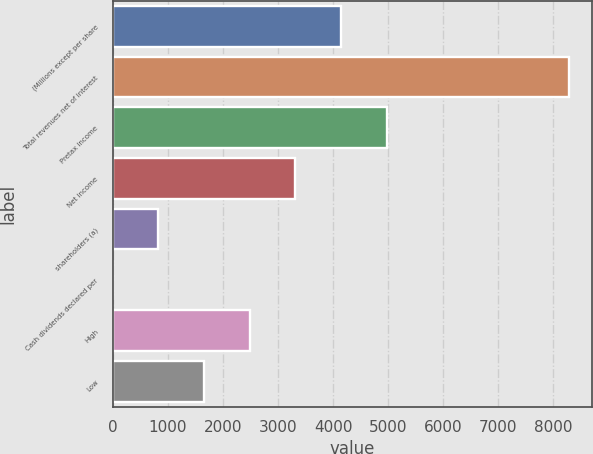Convert chart to OTSL. <chart><loc_0><loc_0><loc_500><loc_500><bar_chart><fcel>(Millions except per share<fcel>Total revenues net of interest<fcel>Pretax income<fcel>Net income<fcel>shareholders (a)<fcel>Cash dividends declared per<fcel>High<fcel>Low<nl><fcel>4142.14<fcel>8284<fcel>4970.51<fcel>3313.77<fcel>828.66<fcel>0.29<fcel>2485.4<fcel>1657.03<nl></chart> 